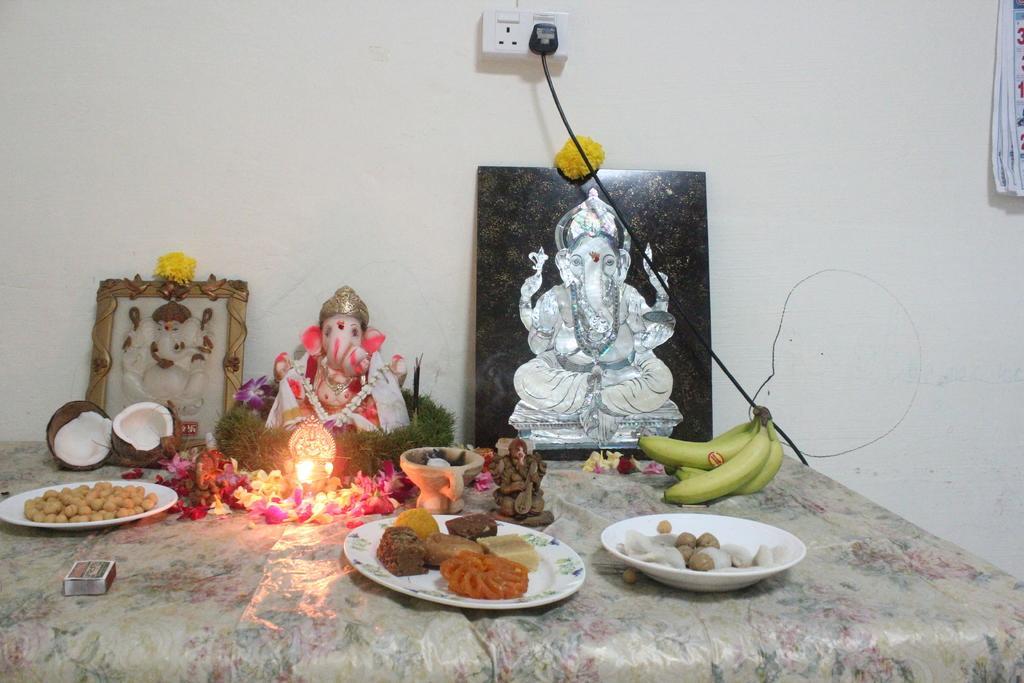Could you give a brief overview of what you see in this image? In this image we can see the socket and calendar attached to the wall. And we can see the table with a cloth, on the table there are photo frames, idols, light, box, flowers, bananas and coconut. And there are some food items in the plate. 